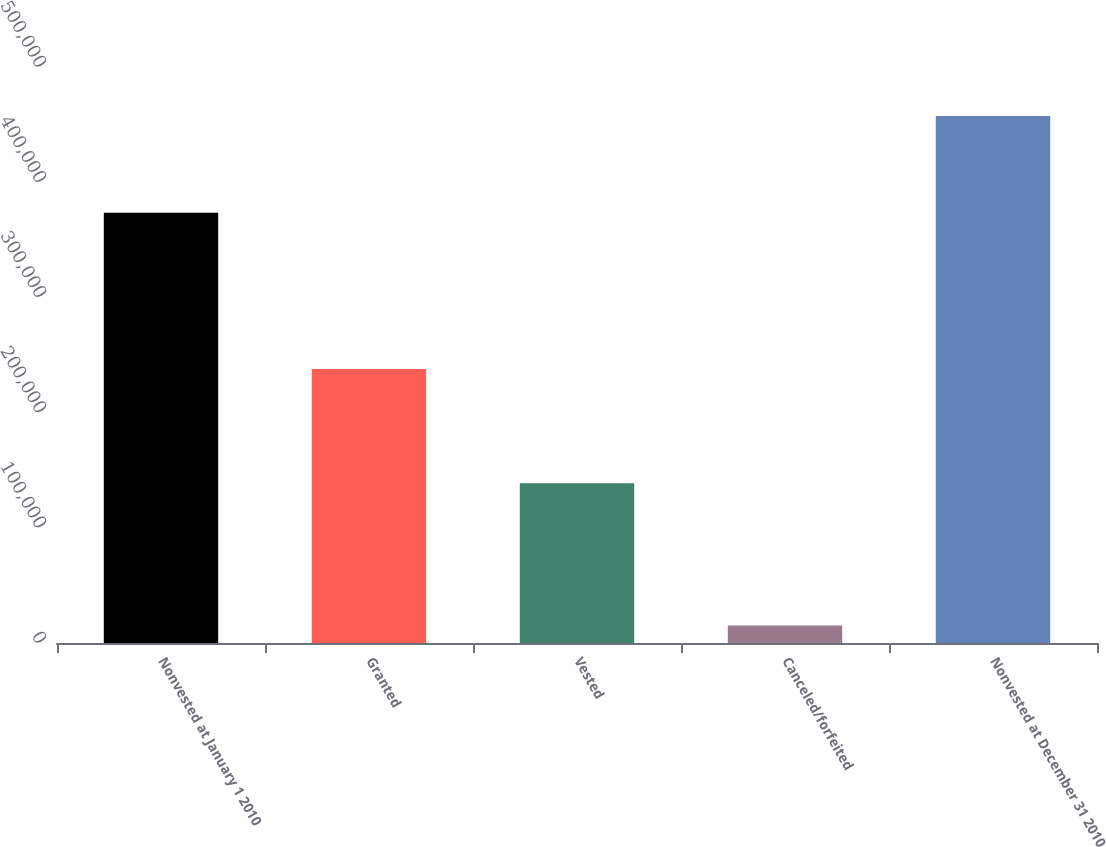Convert chart. <chart><loc_0><loc_0><loc_500><loc_500><bar_chart><fcel>Nonvested at January 1 2010<fcel>Granted<fcel>Vested<fcel>Canceled/forfeited<fcel>Nonvested at December 31 2010<nl><fcel>373558<fcel>237940<fcel>138697<fcel>15230<fcel>457571<nl></chart> 